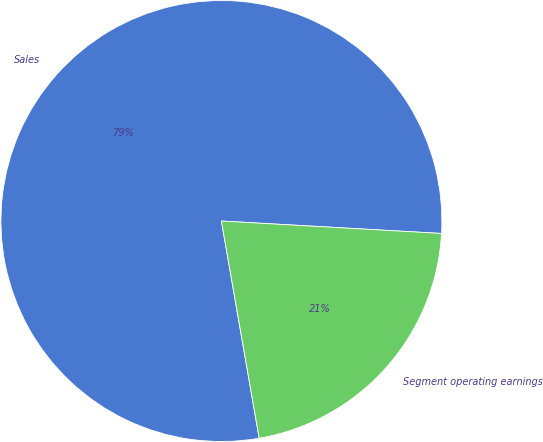Convert chart to OTSL. <chart><loc_0><loc_0><loc_500><loc_500><pie_chart><fcel>Sales<fcel>Segment operating earnings<nl><fcel>78.64%<fcel>21.36%<nl></chart> 